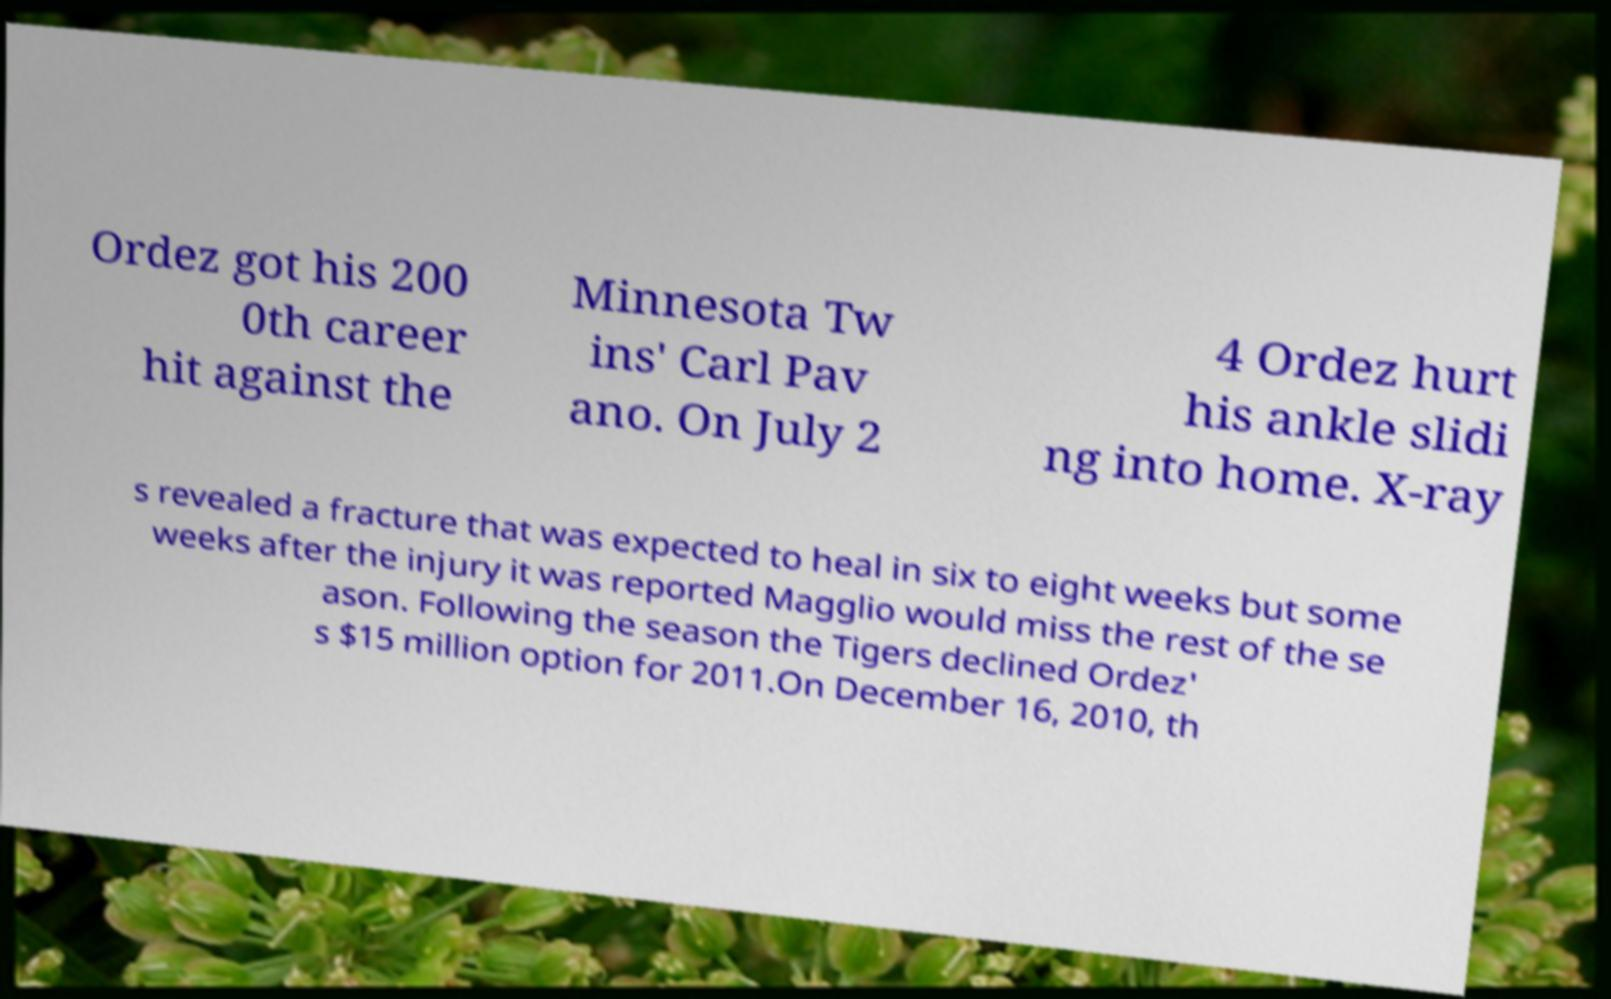Could you extract and type out the text from this image? Ordez got his 200 0th career hit against the Minnesota Tw ins' Carl Pav ano. On July 2 4 Ordez hurt his ankle slidi ng into home. X-ray s revealed a fracture that was expected to heal in six to eight weeks but some weeks after the injury it was reported Magglio would miss the rest of the se ason. Following the season the Tigers declined Ordez' s $15 million option for 2011.On December 16, 2010, th 